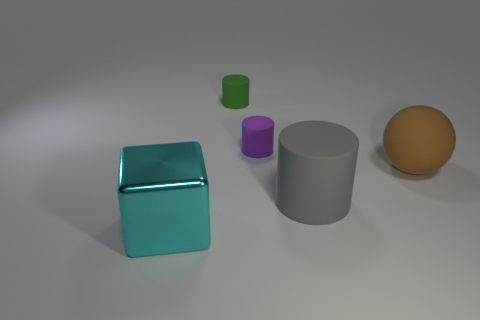Add 1 tiny red metal blocks. How many objects exist? 6 Subtract all cylinders. How many objects are left? 2 Add 2 big matte things. How many big matte things exist? 4 Subtract 1 brown spheres. How many objects are left? 4 Subtract all large blue matte blocks. Subtract all cyan shiny blocks. How many objects are left? 4 Add 2 big brown things. How many big brown things are left? 3 